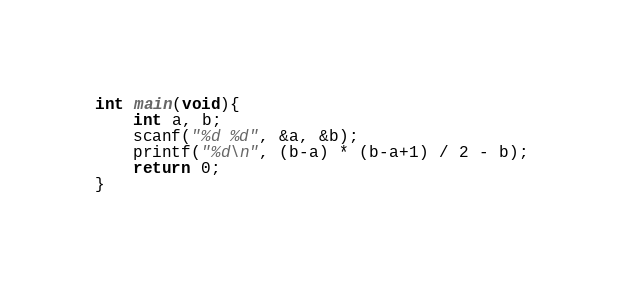<code> <loc_0><loc_0><loc_500><loc_500><_C_>int main(void){
    int a, b;
    scanf("%d %d", &a, &b);
    printf("%d\n", (b-a) * (b-a+1) / 2 - b);
    return 0;
}</code> 